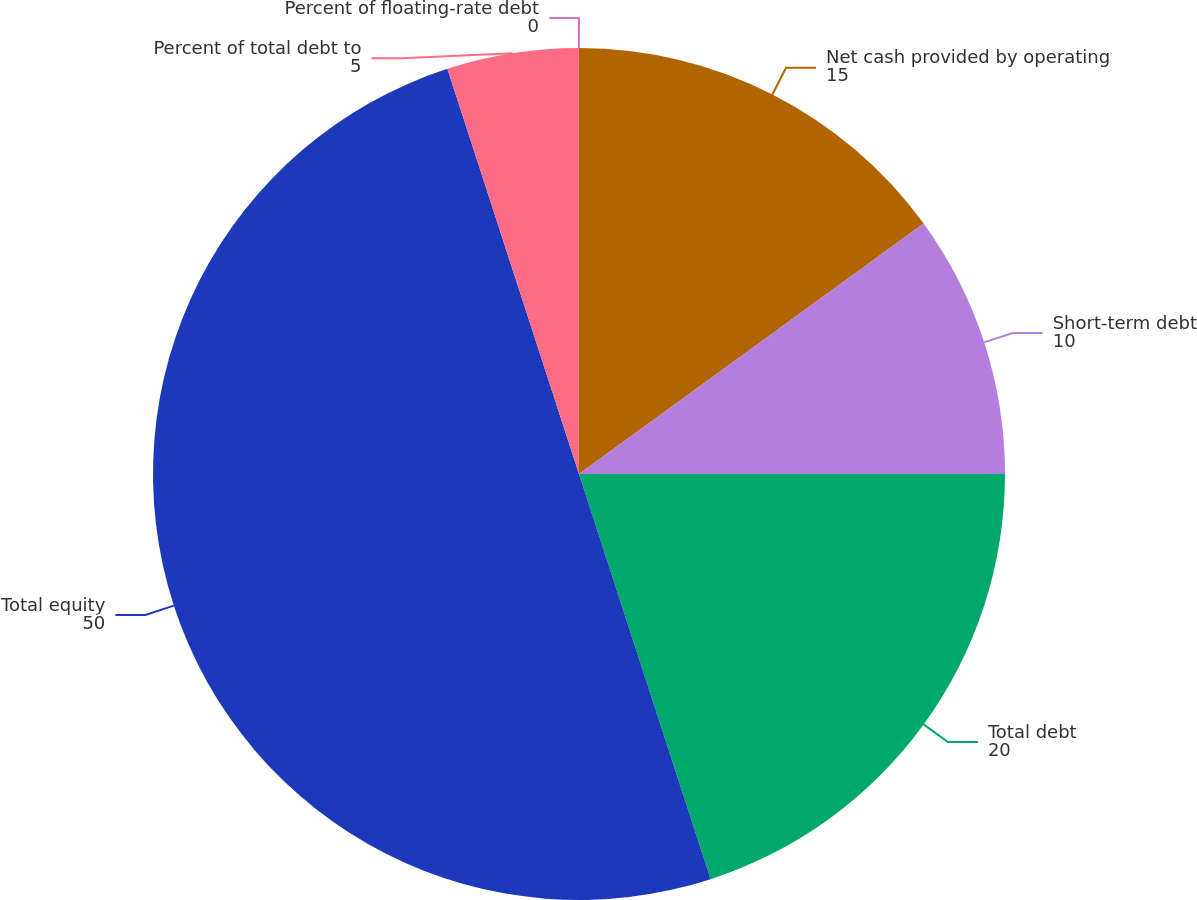<chart> <loc_0><loc_0><loc_500><loc_500><pie_chart><fcel>Net cash provided by operating<fcel>Short-term debt<fcel>Total debt<fcel>Total equity<fcel>Percent of total debt to<fcel>Percent of floating-rate debt<nl><fcel>15.0%<fcel>10.0%<fcel>20.0%<fcel>50.0%<fcel>5.0%<fcel>0.0%<nl></chart> 